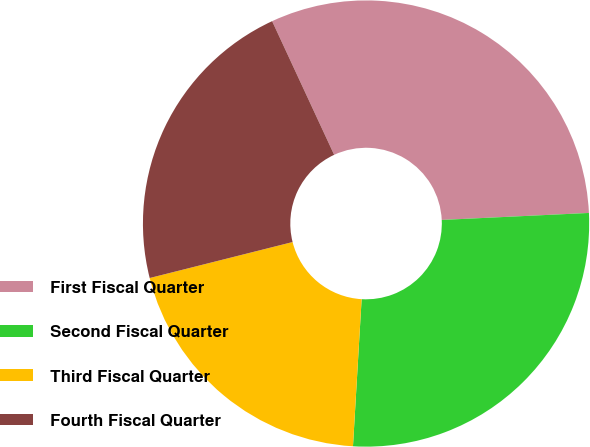Convert chart. <chart><loc_0><loc_0><loc_500><loc_500><pie_chart><fcel>First Fiscal Quarter<fcel>Second Fiscal Quarter<fcel>Third Fiscal Quarter<fcel>Fourth Fiscal Quarter<nl><fcel>31.16%<fcel>26.69%<fcel>20.14%<fcel>22.01%<nl></chart> 